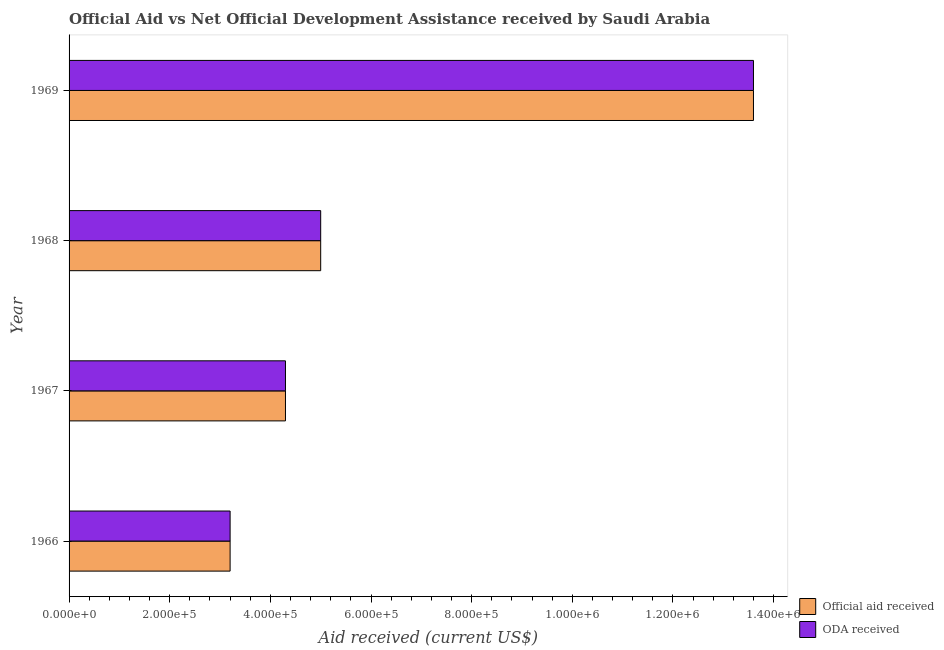Are the number of bars per tick equal to the number of legend labels?
Offer a very short reply. Yes. Are the number of bars on each tick of the Y-axis equal?
Provide a succinct answer. Yes. How many bars are there on the 1st tick from the bottom?
Offer a terse response. 2. What is the label of the 4th group of bars from the top?
Your answer should be very brief. 1966. In how many cases, is the number of bars for a given year not equal to the number of legend labels?
Offer a very short reply. 0. What is the oda received in 1968?
Ensure brevity in your answer.  5.00e+05. Across all years, what is the maximum oda received?
Offer a terse response. 1.36e+06. Across all years, what is the minimum official aid received?
Make the answer very short. 3.20e+05. In which year was the oda received maximum?
Offer a very short reply. 1969. In which year was the oda received minimum?
Your answer should be compact. 1966. What is the total official aid received in the graph?
Keep it short and to the point. 2.61e+06. What is the difference between the oda received in 1968 and that in 1969?
Your answer should be compact. -8.60e+05. What is the difference between the official aid received in 1966 and the oda received in 1968?
Keep it short and to the point. -1.80e+05. What is the average official aid received per year?
Your answer should be very brief. 6.52e+05. In how many years, is the official aid received greater than 1320000 US$?
Provide a succinct answer. 1. What is the ratio of the oda received in 1967 to that in 1968?
Your answer should be compact. 0.86. Is the official aid received in 1966 less than that in 1967?
Provide a succinct answer. Yes. What is the difference between the highest and the second highest official aid received?
Offer a very short reply. 8.60e+05. What is the difference between the highest and the lowest oda received?
Offer a very short reply. 1.04e+06. In how many years, is the oda received greater than the average oda received taken over all years?
Your response must be concise. 1. Is the sum of the oda received in 1966 and 1968 greater than the maximum official aid received across all years?
Your answer should be compact. No. What does the 1st bar from the top in 1967 represents?
Make the answer very short. ODA received. What does the 1st bar from the bottom in 1969 represents?
Make the answer very short. Official aid received. How many bars are there?
Offer a very short reply. 8. What is the difference between two consecutive major ticks on the X-axis?
Provide a short and direct response. 2.00e+05. Does the graph contain grids?
Make the answer very short. No. Where does the legend appear in the graph?
Your response must be concise. Bottom right. How are the legend labels stacked?
Your answer should be very brief. Vertical. What is the title of the graph?
Keep it short and to the point. Official Aid vs Net Official Development Assistance received by Saudi Arabia . What is the label or title of the X-axis?
Provide a succinct answer. Aid received (current US$). What is the Aid received (current US$) of Official aid received in 1966?
Offer a very short reply. 3.20e+05. What is the Aid received (current US$) of ODA received in 1966?
Your answer should be very brief. 3.20e+05. What is the Aid received (current US$) in Official aid received in 1967?
Ensure brevity in your answer.  4.30e+05. What is the Aid received (current US$) in Official aid received in 1969?
Ensure brevity in your answer.  1.36e+06. What is the Aid received (current US$) in ODA received in 1969?
Give a very brief answer. 1.36e+06. Across all years, what is the maximum Aid received (current US$) in Official aid received?
Your response must be concise. 1.36e+06. Across all years, what is the maximum Aid received (current US$) of ODA received?
Your response must be concise. 1.36e+06. What is the total Aid received (current US$) of Official aid received in the graph?
Ensure brevity in your answer.  2.61e+06. What is the total Aid received (current US$) of ODA received in the graph?
Give a very brief answer. 2.61e+06. What is the difference between the Aid received (current US$) of Official aid received in 1966 and that in 1968?
Give a very brief answer. -1.80e+05. What is the difference between the Aid received (current US$) of Official aid received in 1966 and that in 1969?
Give a very brief answer. -1.04e+06. What is the difference between the Aid received (current US$) of ODA received in 1966 and that in 1969?
Your answer should be compact. -1.04e+06. What is the difference between the Aid received (current US$) in Official aid received in 1967 and that in 1969?
Make the answer very short. -9.30e+05. What is the difference between the Aid received (current US$) of ODA received in 1967 and that in 1969?
Keep it short and to the point. -9.30e+05. What is the difference between the Aid received (current US$) of Official aid received in 1968 and that in 1969?
Your answer should be compact. -8.60e+05. What is the difference between the Aid received (current US$) in ODA received in 1968 and that in 1969?
Provide a succinct answer. -8.60e+05. What is the difference between the Aid received (current US$) of Official aid received in 1966 and the Aid received (current US$) of ODA received in 1968?
Ensure brevity in your answer.  -1.80e+05. What is the difference between the Aid received (current US$) of Official aid received in 1966 and the Aid received (current US$) of ODA received in 1969?
Keep it short and to the point. -1.04e+06. What is the difference between the Aid received (current US$) of Official aid received in 1967 and the Aid received (current US$) of ODA received in 1969?
Offer a very short reply. -9.30e+05. What is the difference between the Aid received (current US$) in Official aid received in 1968 and the Aid received (current US$) in ODA received in 1969?
Make the answer very short. -8.60e+05. What is the average Aid received (current US$) in Official aid received per year?
Keep it short and to the point. 6.52e+05. What is the average Aid received (current US$) in ODA received per year?
Your answer should be very brief. 6.52e+05. In the year 1966, what is the difference between the Aid received (current US$) in Official aid received and Aid received (current US$) in ODA received?
Keep it short and to the point. 0. In the year 1967, what is the difference between the Aid received (current US$) of Official aid received and Aid received (current US$) of ODA received?
Give a very brief answer. 0. In the year 1968, what is the difference between the Aid received (current US$) in Official aid received and Aid received (current US$) in ODA received?
Keep it short and to the point. 0. In the year 1969, what is the difference between the Aid received (current US$) in Official aid received and Aid received (current US$) in ODA received?
Provide a short and direct response. 0. What is the ratio of the Aid received (current US$) of Official aid received in 1966 to that in 1967?
Give a very brief answer. 0.74. What is the ratio of the Aid received (current US$) of ODA received in 1966 to that in 1967?
Make the answer very short. 0.74. What is the ratio of the Aid received (current US$) in Official aid received in 1966 to that in 1968?
Offer a terse response. 0.64. What is the ratio of the Aid received (current US$) of ODA received in 1966 to that in 1968?
Your answer should be compact. 0.64. What is the ratio of the Aid received (current US$) in Official aid received in 1966 to that in 1969?
Ensure brevity in your answer.  0.24. What is the ratio of the Aid received (current US$) in ODA received in 1966 to that in 1969?
Give a very brief answer. 0.24. What is the ratio of the Aid received (current US$) in Official aid received in 1967 to that in 1968?
Your answer should be very brief. 0.86. What is the ratio of the Aid received (current US$) of ODA received in 1967 to that in 1968?
Your answer should be compact. 0.86. What is the ratio of the Aid received (current US$) of Official aid received in 1967 to that in 1969?
Ensure brevity in your answer.  0.32. What is the ratio of the Aid received (current US$) of ODA received in 1967 to that in 1969?
Provide a succinct answer. 0.32. What is the ratio of the Aid received (current US$) of Official aid received in 1968 to that in 1969?
Make the answer very short. 0.37. What is the ratio of the Aid received (current US$) of ODA received in 1968 to that in 1969?
Provide a short and direct response. 0.37. What is the difference between the highest and the second highest Aid received (current US$) of Official aid received?
Provide a short and direct response. 8.60e+05. What is the difference between the highest and the second highest Aid received (current US$) of ODA received?
Your answer should be compact. 8.60e+05. What is the difference between the highest and the lowest Aid received (current US$) of Official aid received?
Make the answer very short. 1.04e+06. What is the difference between the highest and the lowest Aid received (current US$) of ODA received?
Make the answer very short. 1.04e+06. 